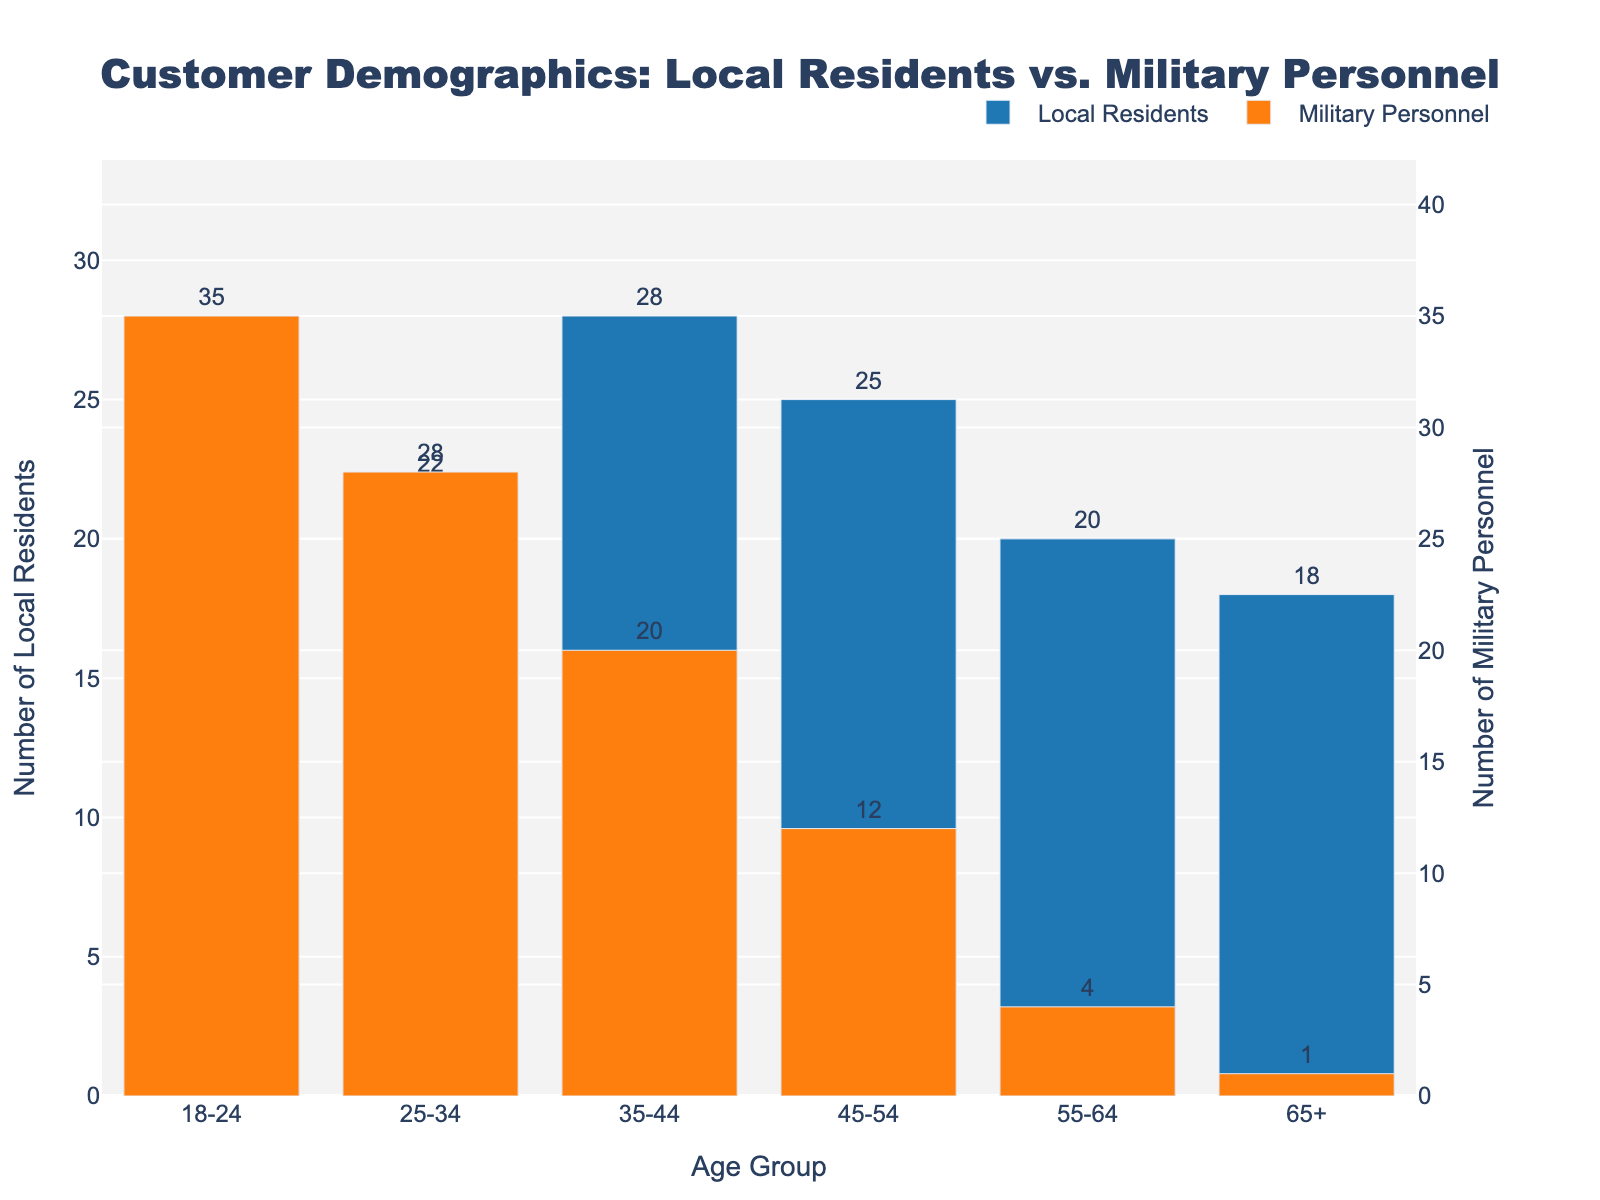What is the total number of local residents in the 25-34 and 35-44 age groups? Adding the number of local residents in the 25-34 age group (22) and the 35-44 age group (28): 22 + 28 = 50
Answer: 50 Which age group has the highest number of military personnel? Looking at the heights of the orange bars, the highest one corresponds to the 18-24 age group with 35 military personnel
Answer: 18-24 By how much does the number of military personnel in the 18-24 age group exceed the number of local residents in the same age group? Subtracting the number of local residents in the 18-24 age group (15) from the number of military personnel in the same age group (35): 35 - 15 = 20
Answer: 20 In which age group are the numbers of local residents and military personnel closest to each other? The age group where the blue and orange bars are most similar in height appears to be 25-34, with local residents at 22 and military personnel at 28, a difference of 6
Answer: 25-34 What is the sum of the number of military personnel in all age groups? Adding the number of military personnel in all age groups: 35 (18-24) + 28 (25-34) + 20 (35-44) + 12 (45-54) + 4 (55-64) + 1 (65+): 35 + 28 + 20 + 12 + 4 + 1 = 100
Answer: 100 Which age group has the lowest number of local residents? The shortest blue bar corresponds to the 65+ age group with 18 local residents
Answer: 65+ Are there any age groups where the number of local residents is less than the number of military personnel? If yes, name them. Comparing the heights of the blue and orange bars, the 18-24 age group has more military personnel (35) than local residents (15)
Answer: 18-24 